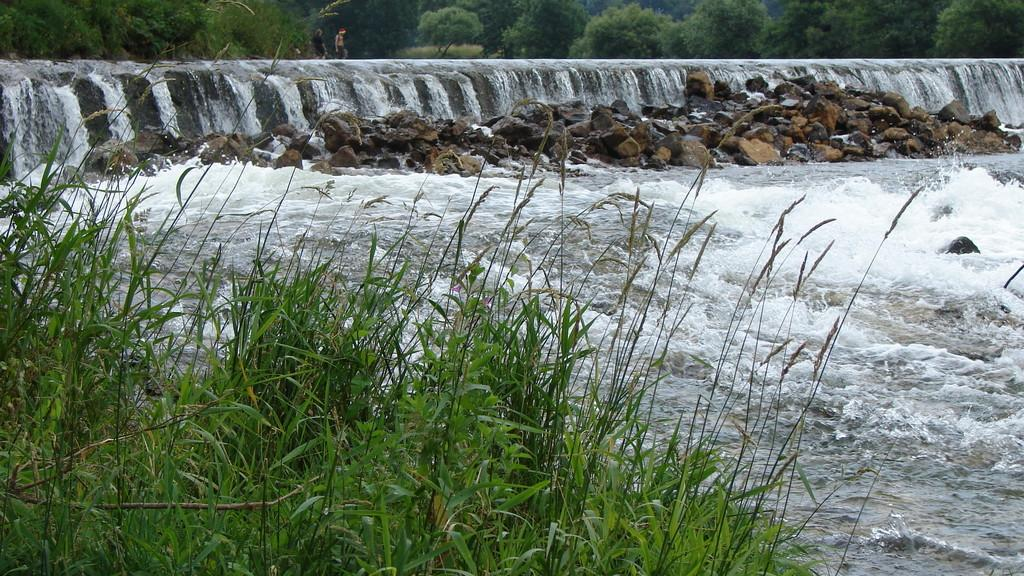What type of vegetation can be seen in the image? There is grass in the image. What other natural elements are present in the image? There are rocks and a waterfall in the image. What can be seen in the background of the image? There are trees in the background of the image. What type of reward can be seen being given to the pig in the image? There is no pig or reward present in the image. What impulse might have led to the creation of the waterfall in the image? There is no information about the creation of the waterfall or any impulses in the provided facts. 